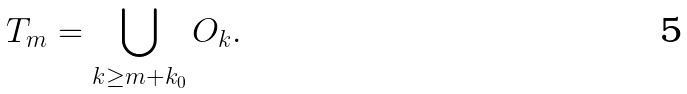<formula> <loc_0><loc_0><loc_500><loc_500>T _ { m } = \bigcup _ { k \geq m + k _ { 0 } } O _ { k } .</formula> 